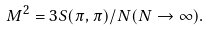<formula> <loc_0><loc_0><loc_500><loc_500>M ^ { 2 } = 3 S ( \pi , \pi ) / N ( N \to \infty ) .</formula> 